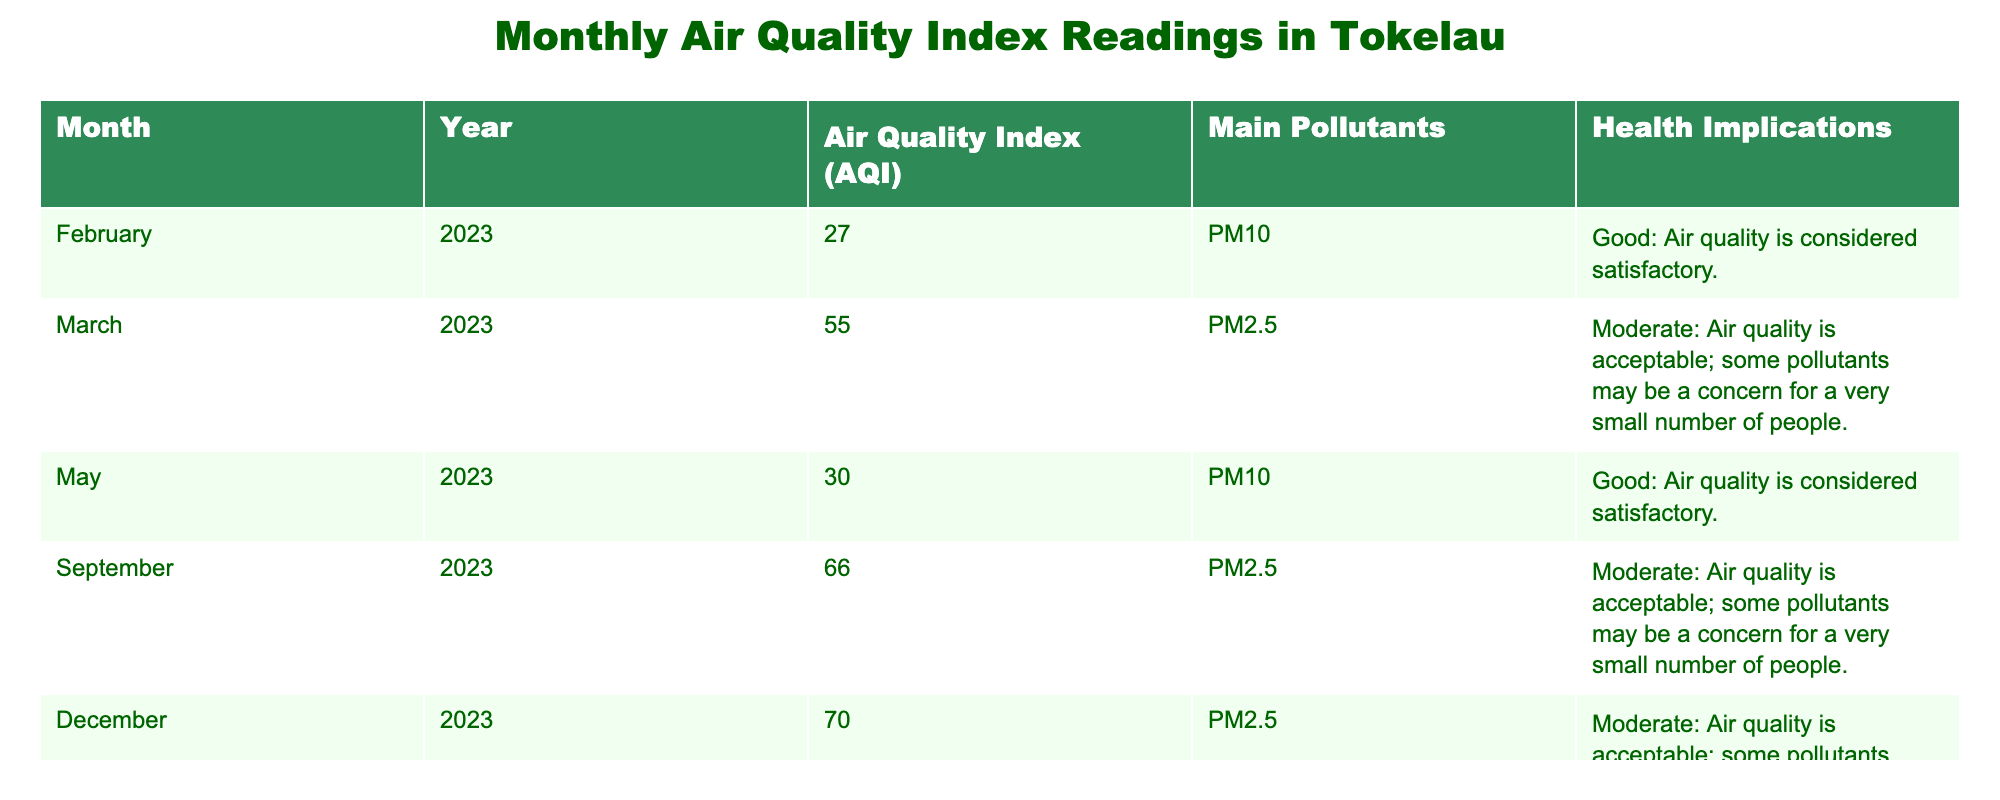What was the Air Quality Index in February 2023? The table shows that the Air Quality Index in February 2023 was 27. This is stated clearly in the row corresponding to that month and year.
Answer: 27 What are the main pollutants recorded in September 2023? According to the table, the main pollutant recorded in September 2023 is PM2.5. This information is found in the relevant row for that date.
Answer: PM2.5 Which month had the highest Air Quality Index value? By examining the table, I notice that December 2023 has the highest Air Quality Index value at 70. Comparing all listed months shows that December surpasses the others.
Answer: December 2023 What is the average Air Quality Index for the year 2023? To find the average AQI for 2023, I first sum the values: (27 + 55 + 30 + 66 + 70) = 248. There are 5 entries for 2023, so I divide to find the average: 248/5 = 49.6.
Answer: 49.6 Is the air quality in Tokelau considered good for the month of May 2023? Referring to the table, it states that the AQI for May 2023 is 30, which is classified as "Good." Therefore, the air quality is considered satisfactory for that month.
Answer: Yes How many months reported a moderate AQI in 2023? The table shows that March, September, and December had a moderate AQI. By counting these months (3 in total), I can confirm that there were three months with moderate ratings.
Answer: 3 Did the Air Quality Index increase from February to March 2023? Observing the table, the AQI for February 2023 is 27, and for March 2023, it is 55. Since 55 is greater than 27, the AQI indeed increased from February to March.
Answer: Yes What health implications are associated with an AQI of 66? In the table, for September 2023, the AQI of 66 indicates a "Moderate" level of air quality, suggesting it is acceptable but may pose health concerns for a small number of people.
Answer: Moderate, some concern What is the change in AQI from May 2023 to September 2023? The AQI for May 2023 is 30, while for September 2023, it is 66. To find the change, I subtract: 66 - 30 = 36. Thus, there is an increase of 36 in AQI from May to September.
Answer: 36 